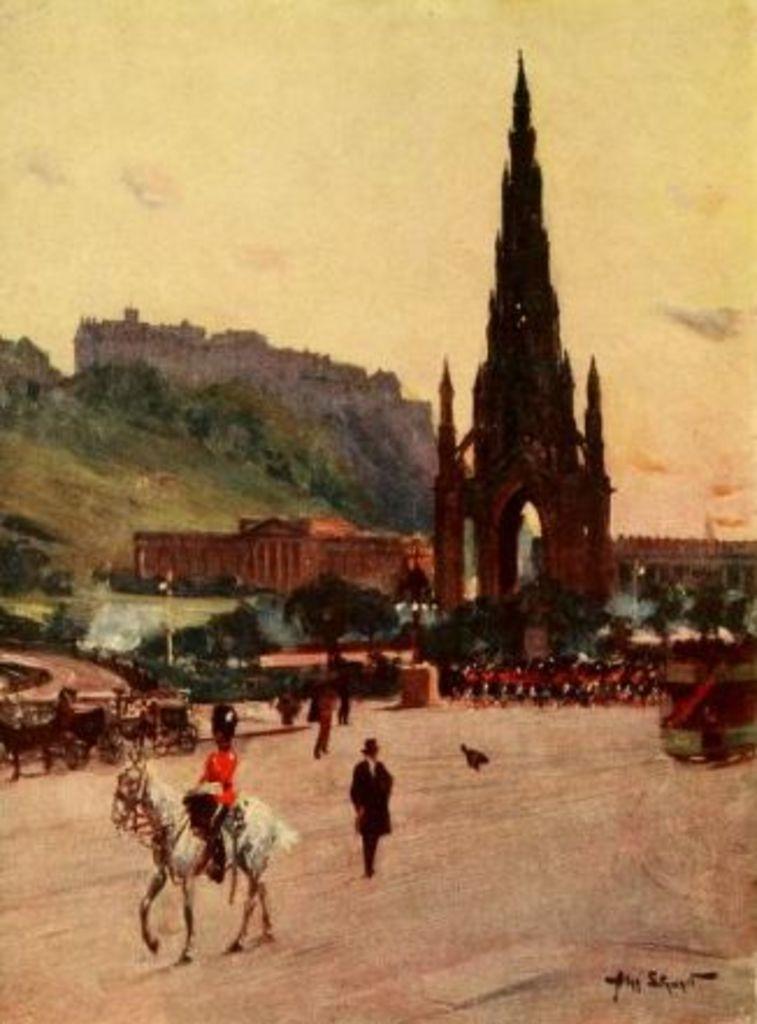Please provide a concise description of this image. In this image we can see a painting. In painting we can see a hill, a sky, a fort, few horses and carts in the image. A person is riding a horse and a person is walking in the painting. There are many objects in the painting. There are many trees in the painting. 